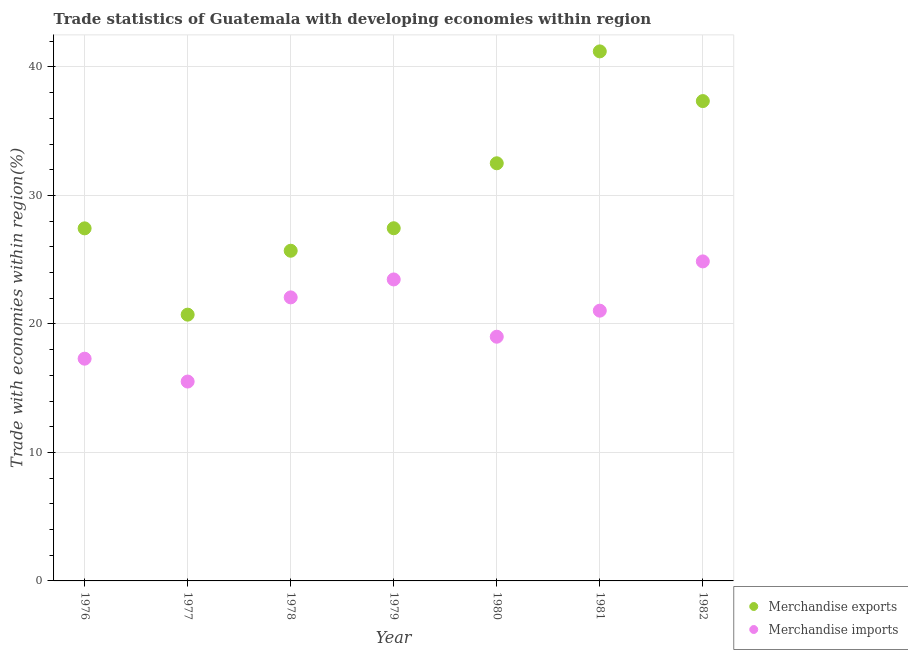How many different coloured dotlines are there?
Give a very brief answer. 2. What is the merchandise imports in 1979?
Your answer should be compact. 23.46. Across all years, what is the maximum merchandise imports?
Provide a succinct answer. 24.87. Across all years, what is the minimum merchandise exports?
Keep it short and to the point. 20.72. In which year was the merchandise imports minimum?
Provide a short and direct response. 1977. What is the total merchandise exports in the graph?
Your answer should be compact. 212.35. What is the difference between the merchandise exports in 1979 and that in 1980?
Keep it short and to the point. -5.06. What is the difference between the merchandise exports in 1982 and the merchandise imports in 1980?
Provide a short and direct response. 18.34. What is the average merchandise exports per year?
Your answer should be very brief. 30.34. In the year 1979, what is the difference between the merchandise imports and merchandise exports?
Your answer should be very brief. -3.99. What is the ratio of the merchandise imports in 1979 to that in 1980?
Your answer should be very brief. 1.23. Is the difference between the merchandise exports in 1976 and 1978 greater than the difference between the merchandise imports in 1976 and 1978?
Your response must be concise. Yes. What is the difference between the highest and the second highest merchandise imports?
Your answer should be compact. 1.4. What is the difference between the highest and the lowest merchandise imports?
Provide a succinct answer. 9.35. In how many years, is the merchandise imports greater than the average merchandise imports taken over all years?
Provide a succinct answer. 4. Is the merchandise imports strictly greater than the merchandise exports over the years?
Your response must be concise. No. Is the merchandise exports strictly less than the merchandise imports over the years?
Your response must be concise. No. What is the difference between two consecutive major ticks on the Y-axis?
Provide a short and direct response. 10. Does the graph contain grids?
Provide a short and direct response. Yes. How are the legend labels stacked?
Make the answer very short. Vertical. What is the title of the graph?
Offer a terse response. Trade statistics of Guatemala with developing economies within region. What is the label or title of the X-axis?
Your answer should be very brief. Year. What is the label or title of the Y-axis?
Your answer should be very brief. Trade with economies within region(%). What is the Trade with economies within region(%) in Merchandise exports in 1976?
Provide a short and direct response. 27.44. What is the Trade with economies within region(%) in Merchandise imports in 1976?
Offer a very short reply. 17.3. What is the Trade with economies within region(%) of Merchandise exports in 1977?
Provide a short and direct response. 20.72. What is the Trade with economies within region(%) in Merchandise imports in 1977?
Give a very brief answer. 15.52. What is the Trade with economies within region(%) in Merchandise exports in 1978?
Offer a very short reply. 25.69. What is the Trade with economies within region(%) of Merchandise imports in 1978?
Your response must be concise. 22.07. What is the Trade with economies within region(%) of Merchandise exports in 1979?
Give a very brief answer. 27.45. What is the Trade with economies within region(%) of Merchandise imports in 1979?
Offer a terse response. 23.46. What is the Trade with economies within region(%) of Merchandise exports in 1980?
Provide a succinct answer. 32.5. What is the Trade with economies within region(%) in Merchandise imports in 1980?
Give a very brief answer. 19. What is the Trade with economies within region(%) of Merchandise exports in 1981?
Your answer should be compact. 41.21. What is the Trade with economies within region(%) in Merchandise imports in 1981?
Keep it short and to the point. 21.03. What is the Trade with economies within region(%) in Merchandise exports in 1982?
Provide a short and direct response. 37.34. What is the Trade with economies within region(%) in Merchandise imports in 1982?
Keep it short and to the point. 24.87. Across all years, what is the maximum Trade with economies within region(%) of Merchandise exports?
Your response must be concise. 41.21. Across all years, what is the maximum Trade with economies within region(%) of Merchandise imports?
Provide a short and direct response. 24.87. Across all years, what is the minimum Trade with economies within region(%) of Merchandise exports?
Offer a very short reply. 20.72. Across all years, what is the minimum Trade with economies within region(%) of Merchandise imports?
Ensure brevity in your answer.  15.52. What is the total Trade with economies within region(%) of Merchandise exports in the graph?
Your response must be concise. 212.35. What is the total Trade with economies within region(%) in Merchandise imports in the graph?
Offer a very short reply. 143.24. What is the difference between the Trade with economies within region(%) of Merchandise exports in 1976 and that in 1977?
Your response must be concise. 6.72. What is the difference between the Trade with economies within region(%) of Merchandise imports in 1976 and that in 1977?
Offer a terse response. 1.78. What is the difference between the Trade with economies within region(%) in Merchandise exports in 1976 and that in 1978?
Your answer should be very brief. 1.74. What is the difference between the Trade with economies within region(%) in Merchandise imports in 1976 and that in 1978?
Your answer should be compact. -4.77. What is the difference between the Trade with economies within region(%) of Merchandise exports in 1976 and that in 1979?
Your answer should be compact. -0.01. What is the difference between the Trade with economies within region(%) of Merchandise imports in 1976 and that in 1979?
Make the answer very short. -6.17. What is the difference between the Trade with economies within region(%) of Merchandise exports in 1976 and that in 1980?
Offer a terse response. -5.06. What is the difference between the Trade with economies within region(%) in Merchandise imports in 1976 and that in 1980?
Offer a terse response. -1.71. What is the difference between the Trade with economies within region(%) of Merchandise exports in 1976 and that in 1981?
Make the answer very short. -13.77. What is the difference between the Trade with economies within region(%) in Merchandise imports in 1976 and that in 1981?
Provide a succinct answer. -3.74. What is the difference between the Trade with economies within region(%) in Merchandise exports in 1976 and that in 1982?
Provide a short and direct response. -9.9. What is the difference between the Trade with economies within region(%) in Merchandise imports in 1976 and that in 1982?
Provide a short and direct response. -7.57. What is the difference between the Trade with economies within region(%) of Merchandise exports in 1977 and that in 1978?
Provide a short and direct response. -4.97. What is the difference between the Trade with economies within region(%) of Merchandise imports in 1977 and that in 1978?
Ensure brevity in your answer.  -6.55. What is the difference between the Trade with economies within region(%) of Merchandise exports in 1977 and that in 1979?
Keep it short and to the point. -6.72. What is the difference between the Trade with economies within region(%) of Merchandise imports in 1977 and that in 1979?
Your answer should be very brief. -7.95. What is the difference between the Trade with economies within region(%) in Merchandise exports in 1977 and that in 1980?
Keep it short and to the point. -11.78. What is the difference between the Trade with economies within region(%) of Merchandise imports in 1977 and that in 1980?
Your answer should be very brief. -3.49. What is the difference between the Trade with economies within region(%) of Merchandise exports in 1977 and that in 1981?
Provide a short and direct response. -20.49. What is the difference between the Trade with economies within region(%) of Merchandise imports in 1977 and that in 1981?
Provide a succinct answer. -5.52. What is the difference between the Trade with economies within region(%) of Merchandise exports in 1977 and that in 1982?
Make the answer very short. -16.62. What is the difference between the Trade with economies within region(%) in Merchandise imports in 1977 and that in 1982?
Your answer should be compact. -9.35. What is the difference between the Trade with economies within region(%) in Merchandise exports in 1978 and that in 1979?
Your answer should be compact. -1.75. What is the difference between the Trade with economies within region(%) of Merchandise imports in 1978 and that in 1979?
Provide a succinct answer. -1.4. What is the difference between the Trade with economies within region(%) of Merchandise exports in 1978 and that in 1980?
Make the answer very short. -6.81. What is the difference between the Trade with economies within region(%) of Merchandise imports in 1978 and that in 1980?
Your response must be concise. 3.06. What is the difference between the Trade with economies within region(%) of Merchandise exports in 1978 and that in 1981?
Your answer should be compact. -15.51. What is the difference between the Trade with economies within region(%) of Merchandise imports in 1978 and that in 1981?
Provide a succinct answer. 1.03. What is the difference between the Trade with economies within region(%) of Merchandise exports in 1978 and that in 1982?
Offer a very short reply. -11.65. What is the difference between the Trade with economies within region(%) of Merchandise imports in 1978 and that in 1982?
Your answer should be compact. -2.8. What is the difference between the Trade with economies within region(%) in Merchandise exports in 1979 and that in 1980?
Keep it short and to the point. -5.06. What is the difference between the Trade with economies within region(%) in Merchandise imports in 1979 and that in 1980?
Offer a terse response. 4.46. What is the difference between the Trade with economies within region(%) in Merchandise exports in 1979 and that in 1981?
Provide a succinct answer. -13.76. What is the difference between the Trade with economies within region(%) in Merchandise imports in 1979 and that in 1981?
Provide a short and direct response. 2.43. What is the difference between the Trade with economies within region(%) of Merchandise exports in 1979 and that in 1982?
Provide a succinct answer. -9.89. What is the difference between the Trade with economies within region(%) of Merchandise imports in 1979 and that in 1982?
Provide a succinct answer. -1.4. What is the difference between the Trade with economies within region(%) in Merchandise exports in 1980 and that in 1981?
Your answer should be very brief. -8.71. What is the difference between the Trade with economies within region(%) in Merchandise imports in 1980 and that in 1981?
Your answer should be very brief. -2.03. What is the difference between the Trade with economies within region(%) of Merchandise exports in 1980 and that in 1982?
Your answer should be very brief. -4.84. What is the difference between the Trade with economies within region(%) in Merchandise imports in 1980 and that in 1982?
Keep it short and to the point. -5.86. What is the difference between the Trade with economies within region(%) in Merchandise exports in 1981 and that in 1982?
Your answer should be very brief. 3.87. What is the difference between the Trade with economies within region(%) of Merchandise imports in 1981 and that in 1982?
Keep it short and to the point. -3.83. What is the difference between the Trade with economies within region(%) of Merchandise exports in 1976 and the Trade with economies within region(%) of Merchandise imports in 1977?
Give a very brief answer. 11.92. What is the difference between the Trade with economies within region(%) of Merchandise exports in 1976 and the Trade with economies within region(%) of Merchandise imports in 1978?
Offer a terse response. 5.37. What is the difference between the Trade with economies within region(%) in Merchandise exports in 1976 and the Trade with economies within region(%) in Merchandise imports in 1979?
Make the answer very short. 3.98. What is the difference between the Trade with economies within region(%) in Merchandise exports in 1976 and the Trade with economies within region(%) in Merchandise imports in 1980?
Provide a succinct answer. 8.43. What is the difference between the Trade with economies within region(%) in Merchandise exports in 1976 and the Trade with economies within region(%) in Merchandise imports in 1981?
Offer a very short reply. 6.41. What is the difference between the Trade with economies within region(%) in Merchandise exports in 1976 and the Trade with economies within region(%) in Merchandise imports in 1982?
Give a very brief answer. 2.57. What is the difference between the Trade with economies within region(%) of Merchandise exports in 1977 and the Trade with economies within region(%) of Merchandise imports in 1978?
Give a very brief answer. -1.34. What is the difference between the Trade with economies within region(%) in Merchandise exports in 1977 and the Trade with economies within region(%) in Merchandise imports in 1979?
Make the answer very short. -2.74. What is the difference between the Trade with economies within region(%) in Merchandise exports in 1977 and the Trade with economies within region(%) in Merchandise imports in 1980?
Ensure brevity in your answer.  1.72. What is the difference between the Trade with economies within region(%) in Merchandise exports in 1977 and the Trade with economies within region(%) in Merchandise imports in 1981?
Provide a short and direct response. -0.31. What is the difference between the Trade with economies within region(%) of Merchandise exports in 1977 and the Trade with economies within region(%) of Merchandise imports in 1982?
Give a very brief answer. -4.14. What is the difference between the Trade with economies within region(%) in Merchandise exports in 1978 and the Trade with economies within region(%) in Merchandise imports in 1979?
Your response must be concise. 2.23. What is the difference between the Trade with economies within region(%) of Merchandise exports in 1978 and the Trade with economies within region(%) of Merchandise imports in 1980?
Provide a short and direct response. 6.69. What is the difference between the Trade with economies within region(%) of Merchandise exports in 1978 and the Trade with economies within region(%) of Merchandise imports in 1981?
Give a very brief answer. 4.66. What is the difference between the Trade with economies within region(%) in Merchandise exports in 1978 and the Trade with economies within region(%) in Merchandise imports in 1982?
Your answer should be very brief. 0.83. What is the difference between the Trade with economies within region(%) of Merchandise exports in 1979 and the Trade with economies within region(%) of Merchandise imports in 1980?
Ensure brevity in your answer.  8.44. What is the difference between the Trade with economies within region(%) of Merchandise exports in 1979 and the Trade with economies within region(%) of Merchandise imports in 1981?
Make the answer very short. 6.41. What is the difference between the Trade with economies within region(%) of Merchandise exports in 1979 and the Trade with economies within region(%) of Merchandise imports in 1982?
Make the answer very short. 2.58. What is the difference between the Trade with economies within region(%) in Merchandise exports in 1980 and the Trade with economies within region(%) in Merchandise imports in 1981?
Your answer should be very brief. 11.47. What is the difference between the Trade with economies within region(%) of Merchandise exports in 1980 and the Trade with economies within region(%) of Merchandise imports in 1982?
Make the answer very short. 7.64. What is the difference between the Trade with economies within region(%) in Merchandise exports in 1981 and the Trade with economies within region(%) in Merchandise imports in 1982?
Offer a terse response. 16.34. What is the average Trade with economies within region(%) of Merchandise exports per year?
Your response must be concise. 30.34. What is the average Trade with economies within region(%) in Merchandise imports per year?
Offer a terse response. 20.46. In the year 1976, what is the difference between the Trade with economies within region(%) of Merchandise exports and Trade with economies within region(%) of Merchandise imports?
Make the answer very short. 10.14. In the year 1977, what is the difference between the Trade with economies within region(%) of Merchandise exports and Trade with economies within region(%) of Merchandise imports?
Your answer should be very brief. 5.21. In the year 1978, what is the difference between the Trade with economies within region(%) of Merchandise exports and Trade with economies within region(%) of Merchandise imports?
Offer a very short reply. 3.63. In the year 1979, what is the difference between the Trade with economies within region(%) in Merchandise exports and Trade with economies within region(%) in Merchandise imports?
Give a very brief answer. 3.99. In the year 1980, what is the difference between the Trade with economies within region(%) of Merchandise exports and Trade with economies within region(%) of Merchandise imports?
Offer a terse response. 13.5. In the year 1981, what is the difference between the Trade with economies within region(%) of Merchandise exports and Trade with economies within region(%) of Merchandise imports?
Ensure brevity in your answer.  20.18. In the year 1982, what is the difference between the Trade with economies within region(%) of Merchandise exports and Trade with economies within region(%) of Merchandise imports?
Make the answer very short. 12.48. What is the ratio of the Trade with economies within region(%) in Merchandise exports in 1976 to that in 1977?
Keep it short and to the point. 1.32. What is the ratio of the Trade with economies within region(%) of Merchandise imports in 1976 to that in 1977?
Ensure brevity in your answer.  1.11. What is the ratio of the Trade with economies within region(%) of Merchandise exports in 1976 to that in 1978?
Make the answer very short. 1.07. What is the ratio of the Trade with economies within region(%) in Merchandise imports in 1976 to that in 1978?
Offer a terse response. 0.78. What is the ratio of the Trade with economies within region(%) of Merchandise exports in 1976 to that in 1979?
Your answer should be very brief. 1. What is the ratio of the Trade with economies within region(%) in Merchandise imports in 1976 to that in 1979?
Keep it short and to the point. 0.74. What is the ratio of the Trade with economies within region(%) of Merchandise exports in 1976 to that in 1980?
Ensure brevity in your answer.  0.84. What is the ratio of the Trade with economies within region(%) of Merchandise imports in 1976 to that in 1980?
Provide a succinct answer. 0.91. What is the ratio of the Trade with economies within region(%) of Merchandise exports in 1976 to that in 1981?
Keep it short and to the point. 0.67. What is the ratio of the Trade with economies within region(%) in Merchandise imports in 1976 to that in 1981?
Provide a short and direct response. 0.82. What is the ratio of the Trade with economies within region(%) in Merchandise exports in 1976 to that in 1982?
Provide a short and direct response. 0.73. What is the ratio of the Trade with economies within region(%) of Merchandise imports in 1976 to that in 1982?
Your answer should be very brief. 0.7. What is the ratio of the Trade with economies within region(%) in Merchandise exports in 1977 to that in 1978?
Keep it short and to the point. 0.81. What is the ratio of the Trade with economies within region(%) in Merchandise imports in 1977 to that in 1978?
Offer a very short reply. 0.7. What is the ratio of the Trade with economies within region(%) of Merchandise exports in 1977 to that in 1979?
Offer a very short reply. 0.76. What is the ratio of the Trade with economies within region(%) of Merchandise imports in 1977 to that in 1979?
Keep it short and to the point. 0.66. What is the ratio of the Trade with economies within region(%) in Merchandise exports in 1977 to that in 1980?
Give a very brief answer. 0.64. What is the ratio of the Trade with economies within region(%) of Merchandise imports in 1977 to that in 1980?
Your answer should be compact. 0.82. What is the ratio of the Trade with economies within region(%) in Merchandise exports in 1977 to that in 1981?
Ensure brevity in your answer.  0.5. What is the ratio of the Trade with economies within region(%) of Merchandise imports in 1977 to that in 1981?
Provide a short and direct response. 0.74. What is the ratio of the Trade with economies within region(%) of Merchandise exports in 1977 to that in 1982?
Your answer should be very brief. 0.55. What is the ratio of the Trade with economies within region(%) in Merchandise imports in 1977 to that in 1982?
Your answer should be very brief. 0.62. What is the ratio of the Trade with economies within region(%) in Merchandise exports in 1978 to that in 1979?
Your answer should be very brief. 0.94. What is the ratio of the Trade with economies within region(%) in Merchandise imports in 1978 to that in 1979?
Your answer should be very brief. 0.94. What is the ratio of the Trade with economies within region(%) of Merchandise exports in 1978 to that in 1980?
Offer a terse response. 0.79. What is the ratio of the Trade with economies within region(%) of Merchandise imports in 1978 to that in 1980?
Ensure brevity in your answer.  1.16. What is the ratio of the Trade with economies within region(%) of Merchandise exports in 1978 to that in 1981?
Offer a very short reply. 0.62. What is the ratio of the Trade with economies within region(%) of Merchandise imports in 1978 to that in 1981?
Ensure brevity in your answer.  1.05. What is the ratio of the Trade with economies within region(%) in Merchandise exports in 1978 to that in 1982?
Give a very brief answer. 0.69. What is the ratio of the Trade with economies within region(%) of Merchandise imports in 1978 to that in 1982?
Make the answer very short. 0.89. What is the ratio of the Trade with economies within region(%) of Merchandise exports in 1979 to that in 1980?
Offer a very short reply. 0.84. What is the ratio of the Trade with economies within region(%) of Merchandise imports in 1979 to that in 1980?
Offer a terse response. 1.23. What is the ratio of the Trade with economies within region(%) in Merchandise exports in 1979 to that in 1981?
Offer a very short reply. 0.67. What is the ratio of the Trade with economies within region(%) of Merchandise imports in 1979 to that in 1981?
Provide a succinct answer. 1.12. What is the ratio of the Trade with economies within region(%) of Merchandise exports in 1979 to that in 1982?
Your answer should be compact. 0.73. What is the ratio of the Trade with economies within region(%) of Merchandise imports in 1979 to that in 1982?
Keep it short and to the point. 0.94. What is the ratio of the Trade with economies within region(%) in Merchandise exports in 1980 to that in 1981?
Offer a very short reply. 0.79. What is the ratio of the Trade with economies within region(%) of Merchandise imports in 1980 to that in 1981?
Keep it short and to the point. 0.9. What is the ratio of the Trade with economies within region(%) of Merchandise exports in 1980 to that in 1982?
Offer a very short reply. 0.87. What is the ratio of the Trade with economies within region(%) of Merchandise imports in 1980 to that in 1982?
Ensure brevity in your answer.  0.76. What is the ratio of the Trade with economies within region(%) in Merchandise exports in 1981 to that in 1982?
Your answer should be compact. 1.1. What is the ratio of the Trade with economies within region(%) in Merchandise imports in 1981 to that in 1982?
Your answer should be compact. 0.85. What is the difference between the highest and the second highest Trade with economies within region(%) of Merchandise exports?
Keep it short and to the point. 3.87. What is the difference between the highest and the second highest Trade with economies within region(%) of Merchandise imports?
Your answer should be very brief. 1.4. What is the difference between the highest and the lowest Trade with economies within region(%) in Merchandise exports?
Offer a terse response. 20.49. What is the difference between the highest and the lowest Trade with economies within region(%) of Merchandise imports?
Your response must be concise. 9.35. 